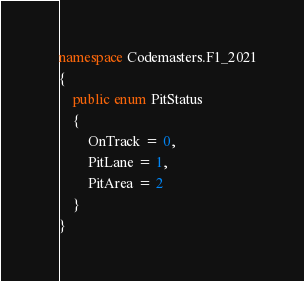<code> <loc_0><loc_0><loc_500><loc_500><_C#_>
namespace Codemasters.F1_2021
{
    public enum PitStatus
    {
        OnTrack = 0,
        PitLane = 1,
        PitArea = 2
    }
}</code> 